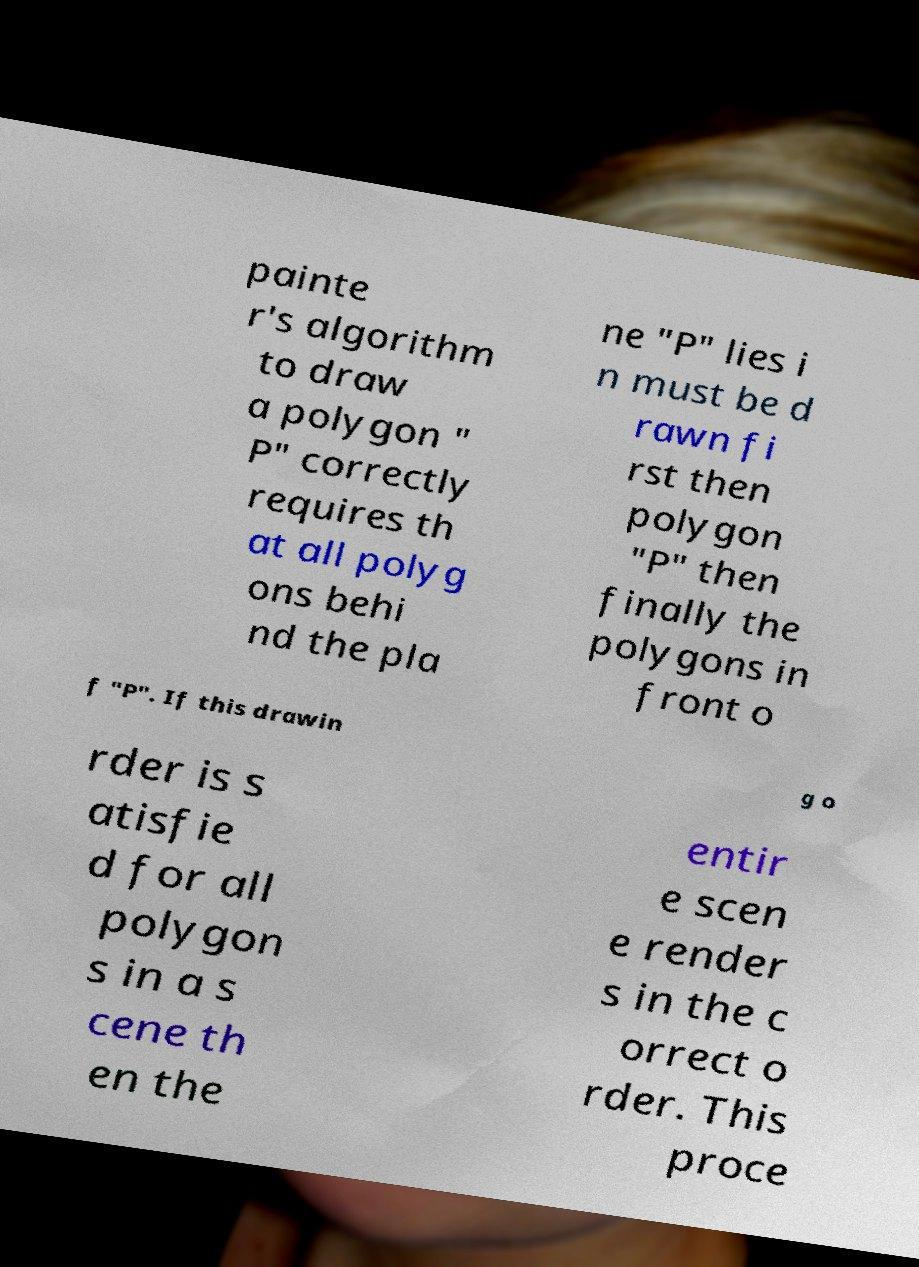Could you assist in decoding the text presented in this image and type it out clearly? painte r's algorithm to draw a polygon " P" correctly requires th at all polyg ons behi nd the pla ne "P" lies i n must be d rawn fi rst then polygon "P" then finally the polygons in front o f "P". If this drawin g o rder is s atisfie d for all polygon s in a s cene th en the entir e scen e render s in the c orrect o rder. This proce 